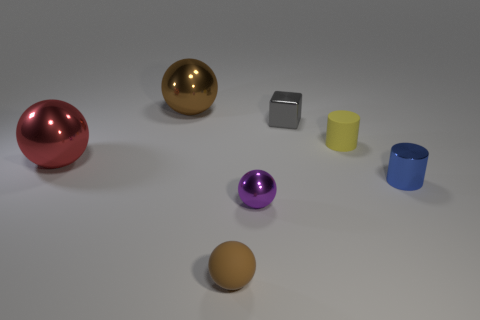Add 2 yellow cylinders. How many objects exist? 9 Subtract all balls. How many objects are left? 3 Subtract 1 purple spheres. How many objects are left? 6 Subtract all big spheres. Subtract all tiny blocks. How many objects are left? 4 Add 7 tiny purple spheres. How many tiny purple spheres are left? 8 Add 6 small red matte cylinders. How many small red matte cylinders exist? 6 